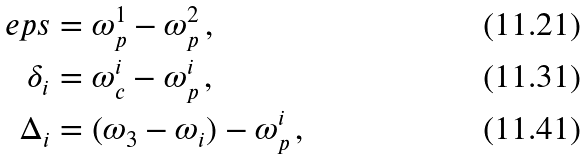<formula> <loc_0><loc_0><loc_500><loc_500>\ e p s & = \omega _ { p } ^ { 1 } - \omega _ { p } ^ { 2 } \, , \\ \delta _ { i } & = \omega _ { c } ^ { i } - \omega _ { p } ^ { i } \, , \\ \Delta _ { i } & = ( \omega _ { 3 } - \omega _ { i } ) - \omega _ { p } ^ { i } \, ,</formula> 